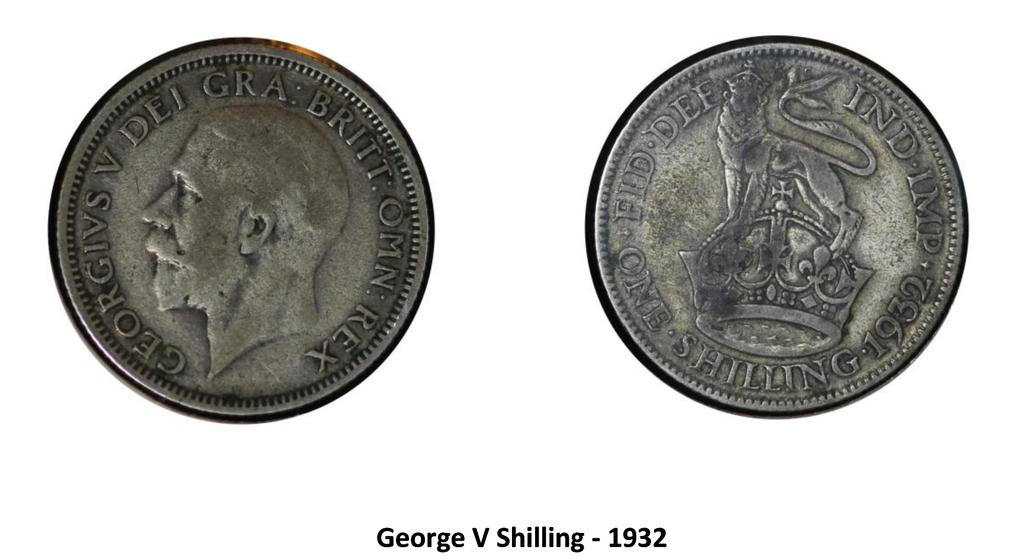<image>
Relay a brief, clear account of the picture shown. Two coins are depicted above text that reads George V Shilling - 1932. 